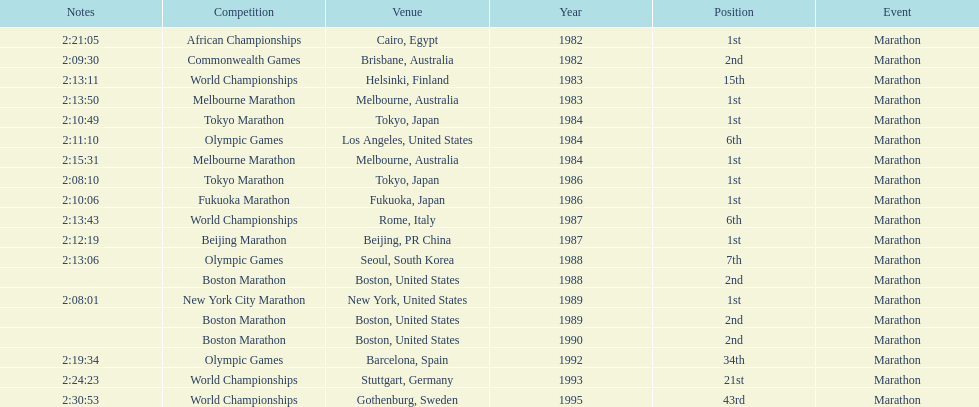How many times in total did ikangaa run the marathon in the olympic games? 3. 